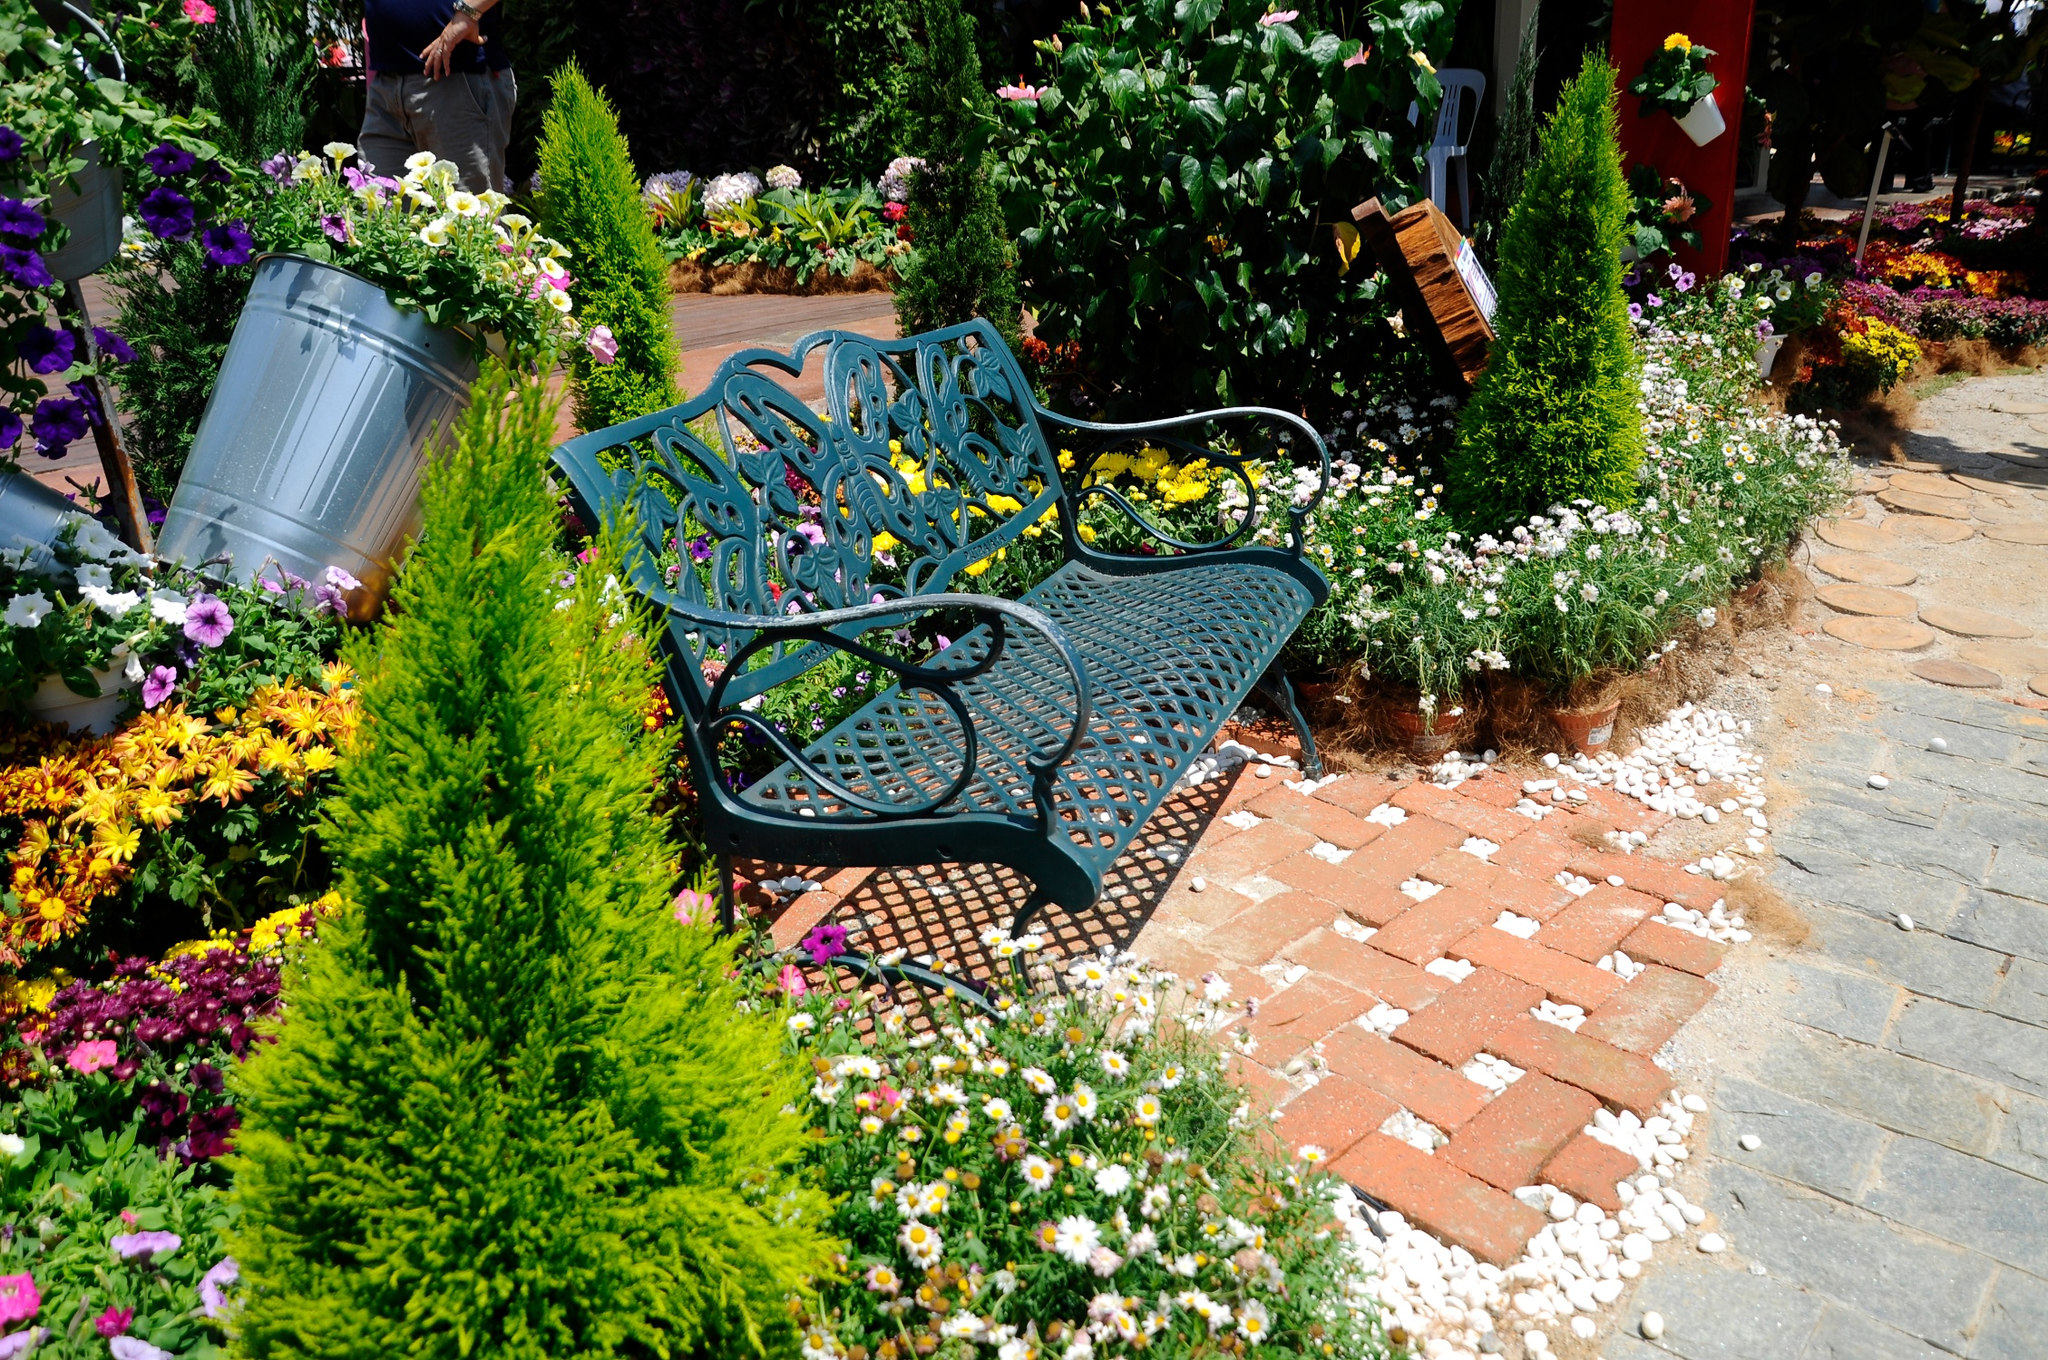Can you elaborate on the elements of the picture provided? The image captures an idyllic garden scene bathed in sunlight. At its heart lies a striking blue metal bench, featuring intricate leaf and flower patterns on its backrest. This bench stands out vividly against the lush, colorful surroundings. The garden is alive with a medley of pink, yellow, and purple flowers, flourishing amidst dense green foliage. The ground is meticulously adorned with white pebbles, which provide a delightful contrast to the earthy tones of the brick pathway running alongside. Photographed from a low angle, the scene evokes a feeling of being enveloped by the garden's tranquility and beauty. A curious landmark identifier, 'sa_12589,' is present, though it doesn't disclose any additional context about the location or historical importance of this serene garden sanctuary. 